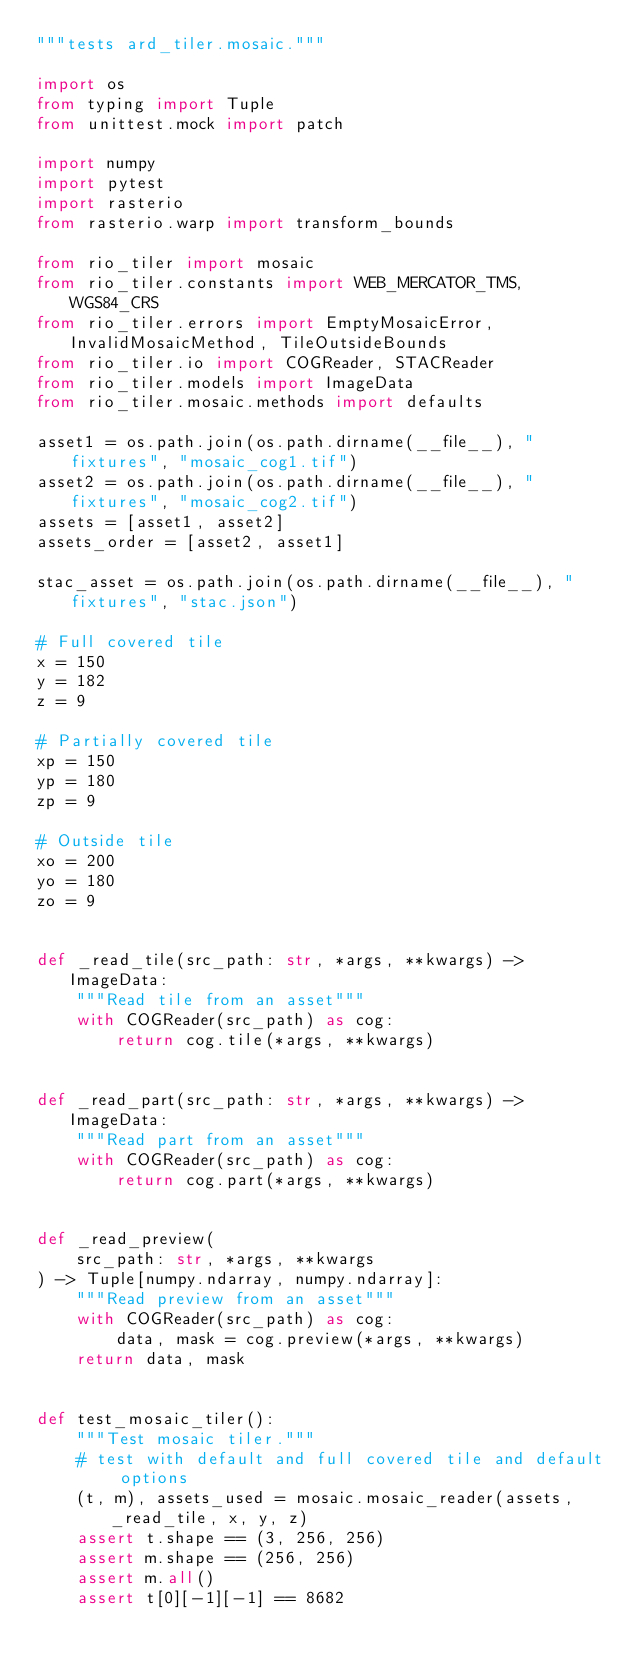<code> <loc_0><loc_0><loc_500><loc_500><_Python_>"""tests ard_tiler.mosaic."""

import os
from typing import Tuple
from unittest.mock import patch

import numpy
import pytest
import rasterio
from rasterio.warp import transform_bounds

from rio_tiler import mosaic
from rio_tiler.constants import WEB_MERCATOR_TMS, WGS84_CRS
from rio_tiler.errors import EmptyMosaicError, InvalidMosaicMethod, TileOutsideBounds
from rio_tiler.io import COGReader, STACReader
from rio_tiler.models import ImageData
from rio_tiler.mosaic.methods import defaults

asset1 = os.path.join(os.path.dirname(__file__), "fixtures", "mosaic_cog1.tif")
asset2 = os.path.join(os.path.dirname(__file__), "fixtures", "mosaic_cog2.tif")
assets = [asset1, asset2]
assets_order = [asset2, asset1]

stac_asset = os.path.join(os.path.dirname(__file__), "fixtures", "stac.json")

# Full covered tile
x = 150
y = 182
z = 9

# Partially covered tile
xp = 150
yp = 180
zp = 9

# Outside tile
xo = 200
yo = 180
zo = 9


def _read_tile(src_path: str, *args, **kwargs) -> ImageData:
    """Read tile from an asset"""
    with COGReader(src_path) as cog:
        return cog.tile(*args, **kwargs)


def _read_part(src_path: str, *args, **kwargs) -> ImageData:
    """Read part from an asset"""
    with COGReader(src_path) as cog:
        return cog.part(*args, **kwargs)


def _read_preview(
    src_path: str, *args, **kwargs
) -> Tuple[numpy.ndarray, numpy.ndarray]:
    """Read preview from an asset"""
    with COGReader(src_path) as cog:
        data, mask = cog.preview(*args, **kwargs)
    return data, mask


def test_mosaic_tiler():
    """Test mosaic tiler."""
    # test with default and full covered tile and default options
    (t, m), assets_used = mosaic.mosaic_reader(assets, _read_tile, x, y, z)
    assert t.shape == (3, 256, 256)
    assert m.shape == (256, 256)
    assert m.all()
    assert t[0][-1][-1] == 8682
</code> 